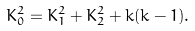Convert formula to latex. <formula><loc_0><loc_0><loc_500><loc_500>K _ { 0 } ^ { 2 } = K _ { 1 } ^ { 2 } + K _ { 2 } ^ { 2 } + k ( k - 1 ) .</formula> 